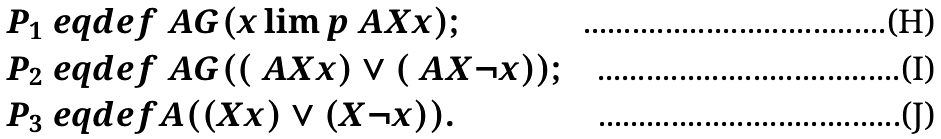Convert formula to latex. <formula><loc_0><loc_0><loc_500><loc_500>P _ { 1 } & \ e q d e f \ A G ( x \lim p \ A X x ) ; \\ P _ { 2 } & \ e q d e f \ A G ( ( \ A X x ) \lor ( \ A X \neg x ) ) ; \\ P _ { 3 } & \ e q d e f A ( ( X x ) \lor ( X \neg x ) ) .</formula> 